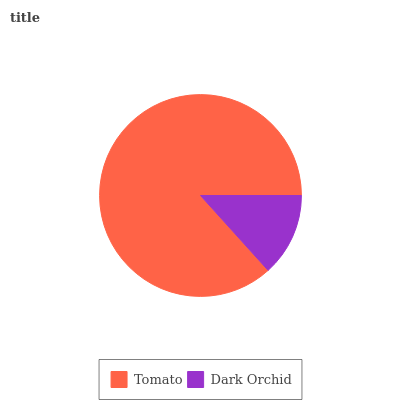Is Dark Orchid the minimum?
Answer yes or no. Yes. Is Tomato the maximum?
Answer yes or no. Yes. Is Dark Orchid the maximum?
Answer yes or no. No. Is Tomato greater than Dark Orchid?
Answer yes or no. Yes. Is Dark Orchid less than Tomato?
Answer yes or no. Yes. Is Dark Orchid greater than Tomato?
Answer yes or no. No. Is Tomato less than Dark Orchid?
Answer yes or no. No. Is Tomato the high median?
Answer yes or no. Yes. Is Dark Orchid the low median?
Answer yes or no. Yes. Is Dark Orchid the high median?
Answer yes or no. No. Is Tomato the low median?
Answer yes or no. No. 